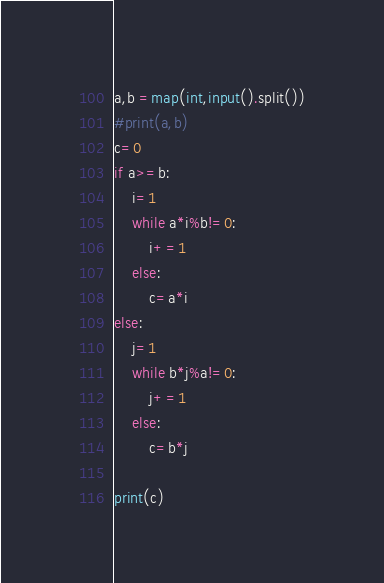Convert code to text. <code><loc_0><loc_0><loc_500><loc_500><_Python_>a,b =map(int,input().split())
#print(a,b)
c=0
if a>=b:
    i=1
    while a*i%b!=0:
        i+=1
    else:
        c=a*i
else:
    j=1
    while b*j%a!=0:
        j+=1
    else:
        c=b*j
    
print(c)</code> 